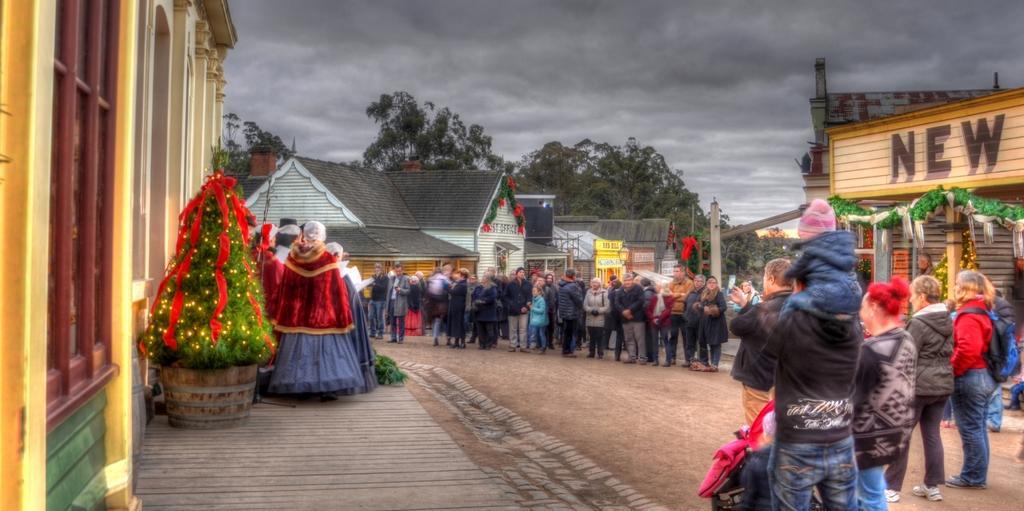Can you describe this image briefly? We can see people,left side of the image we can see Christmas tree with decorative items and window. Background we can see houses,trees and sky is cloudy. 